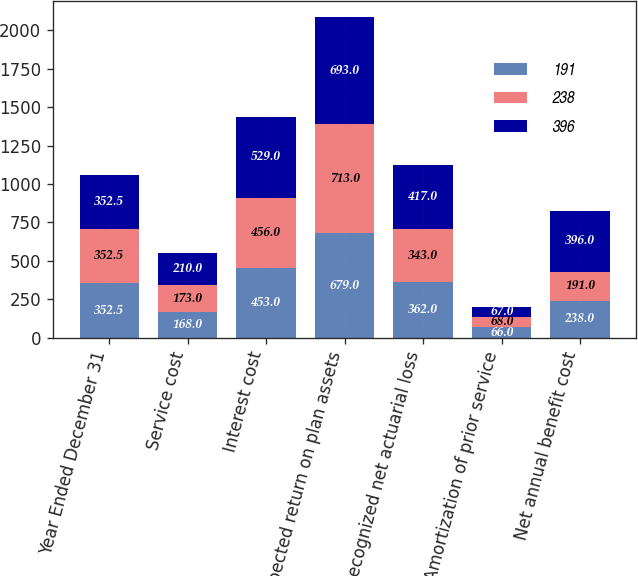Convert chart. <chart><loc_0><loc_0><loc_500><loc_500><stacked_bar_chart><ecel><fcel>Year Ended December 31<fcel>Service cost<fcel>Interest cost<fcel>Expected return on plan assets<fcel>Recognized net actuarial loss<fcel>Amortization of prior service<fcel>Net annual benefit cost<nl><fcel>191<fcel>352.5<fcel>168<fcel>453<fcel>679<fcel>362<fcel>66<fcel>238<nl><fcel>238<fcel>352.5<fcel>173<fcel>456<fcel>713<fcel>343<fcel>68<fcel>191<nl><fcel>396<fcel>352.5<fcel>210<fcel>529<fcel>693<fcel>417<fcel>67<fcel>396<nl></chart> 